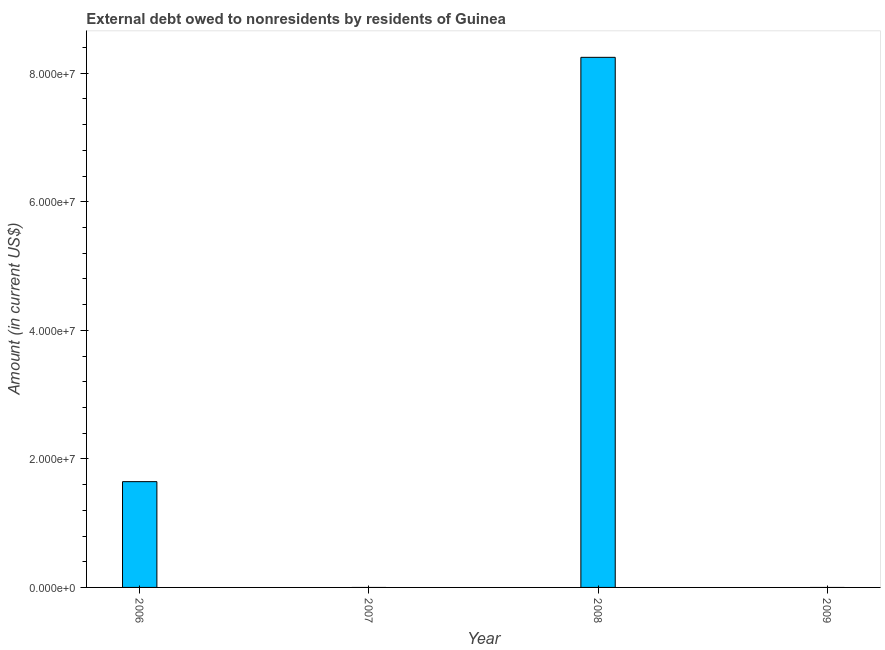What is the title of the graph?
Offer a very short reply. External debt owed to nonresidents by residents of Guinea. What is the label or title of the X-axis?
Your answer should be compact. Year. What is the label or title of the Y-axis?
Provide a short and direct response. Amount (in current US$). What is the debt in 2009?
Provide a succinct answer. 0. Across all years, what is the maximum debt?
Your answer should be compact. 8.25e+07. What is the sum of the debt?
Provide a short and direct response. 9.89e+07. What is the difference between the debt in 2006 and 2008?
Provide a short and direct response. -6.60e+07. What is the average debt per year?
Your answer should be very brief. 2.47e+07. What is the median debt?
Your answer should be very brief. 8.23e+06. In how many years, is the debt greater than 32000000 US$?
Your answer should be compact. 1. What is the difference between the highest and the lowest debt?
Provide a succinct answer. 8.25e+07. In how many years, is the debt greater than the average debt taken over all years?
Ensure brevity in your answer.  1. How many bars are there?
Your answer should be compact. 2. Are all the bars in the graph horizontal?
Offer a very short reply. No. How many years are there in the graph?
Your answer should be very brief. 4. Are the values on the major ticks of Y-axis written in scientific E-notation?
Provide a short and direct response. Yes. What is the Amount (in current US$) in 2006?
Provide a short and direct response. 1.65e+07. What is the Amount (in current US$) in 2007?
Keep it short and to the point. 0. What is the Amount (in current US$) in 2008?
Your response must be concise. 8.25e+07. What is the difference between the Amount (in current US$) in 2006 and 2008?
Ensure brevity in your answer.  -6.60e+07. What is the ratio of the Amount (in current US$) in 2006 to that in 2008?
Offer a terse response. 0.2. 